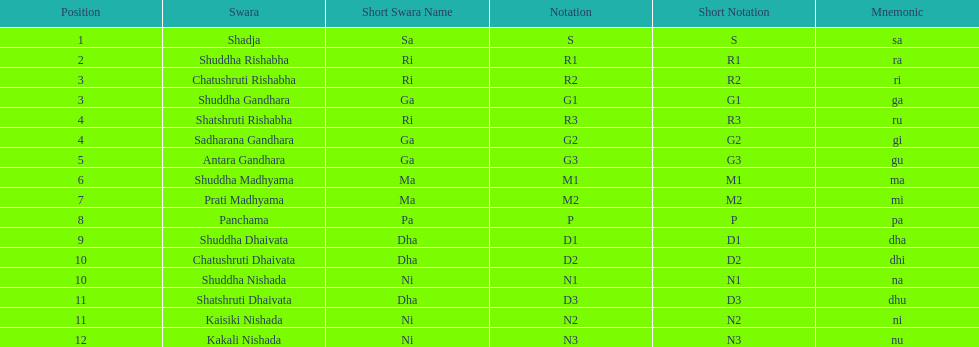Which swara holds the last position? Kakali Nishada. 